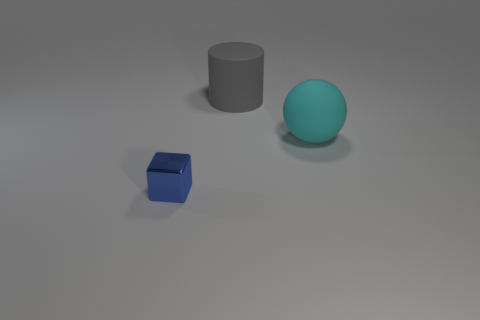Add 1 tiny gray rubber things. How many objects exist? 4 Subtract all cylinders. How many objects are left? 2 Subtract 1 balls. How many balls are left? 0 Subtract 0 yellow cylinders. How many objects are left? 3 Subtract all purple cylinders. Subtract all blue cubes. How many cylinders are left? 1 Subtract all tiny cubes. Subtract all blue cubes. How many objects are left? 1 Add 2 blue metallic blocks. How many blue metallic blocks are left? 3 Add 1 big cyan rubber spheres. How many big cyan rubber spheres exist? 2 